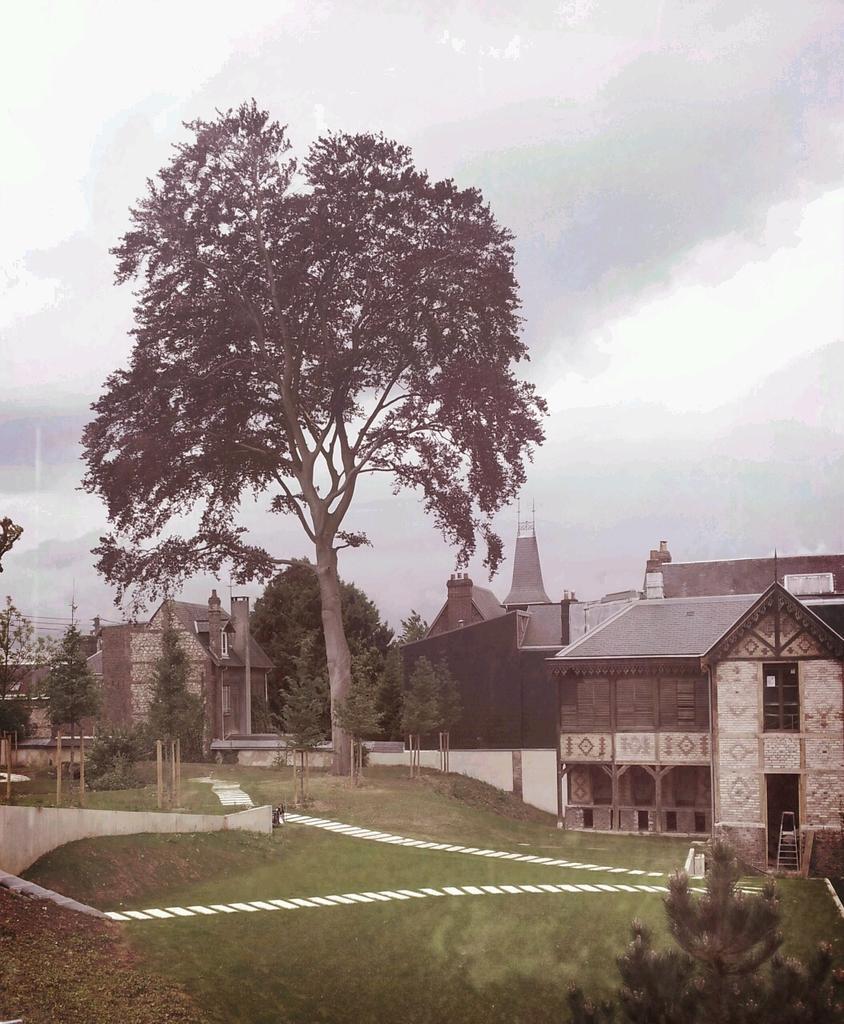How would you summarize this image in a sentence or two? In the background we can see sky, trees and houses. Here we can see poles and grass. In the bottom right corner of the picture we can see a plant. 